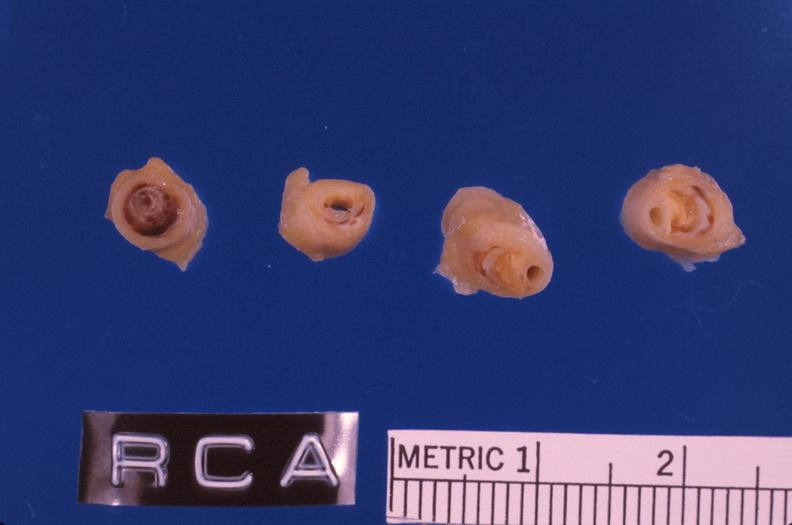s vasculature present?
Answer the question using a single word or phrase. Yes 